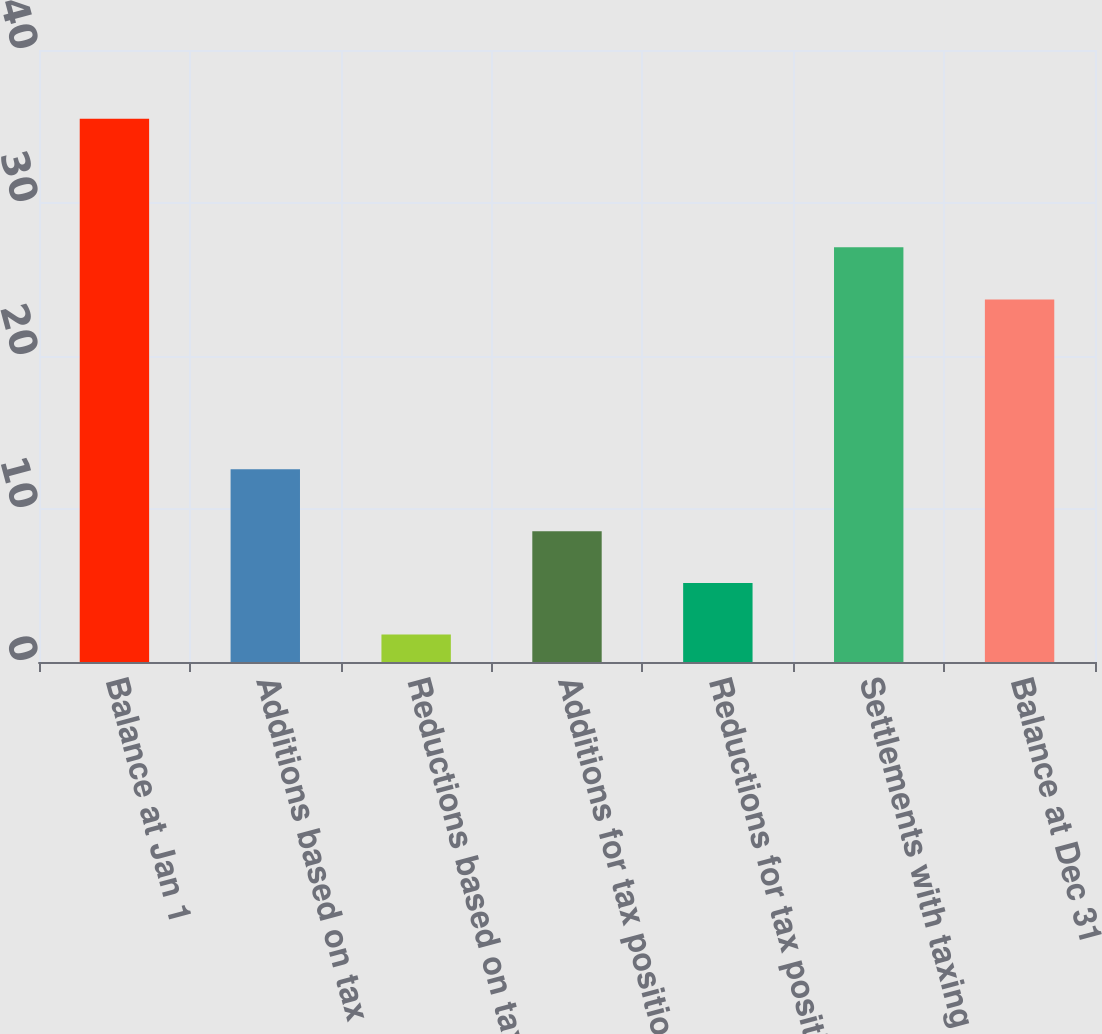Convert chart to OTSL. <chart><loc_0><loc_0><loc_500><loc_500><bar_chart><fcel>Balance at Jan 1<fcel>Additions based on tax<fcel>Reductions based on tax<fcel>Additions for tax positions of<fcel>Reductions for tax positions<fcel>Settlements with taxing<fcel>Balance at Dec 31<nl><fcel>35.5<fcel>12.6<fcel>1.8<fcel>8.54<fcel>5.17<fcel>27.1<fcel>23.7<nl></chart> 